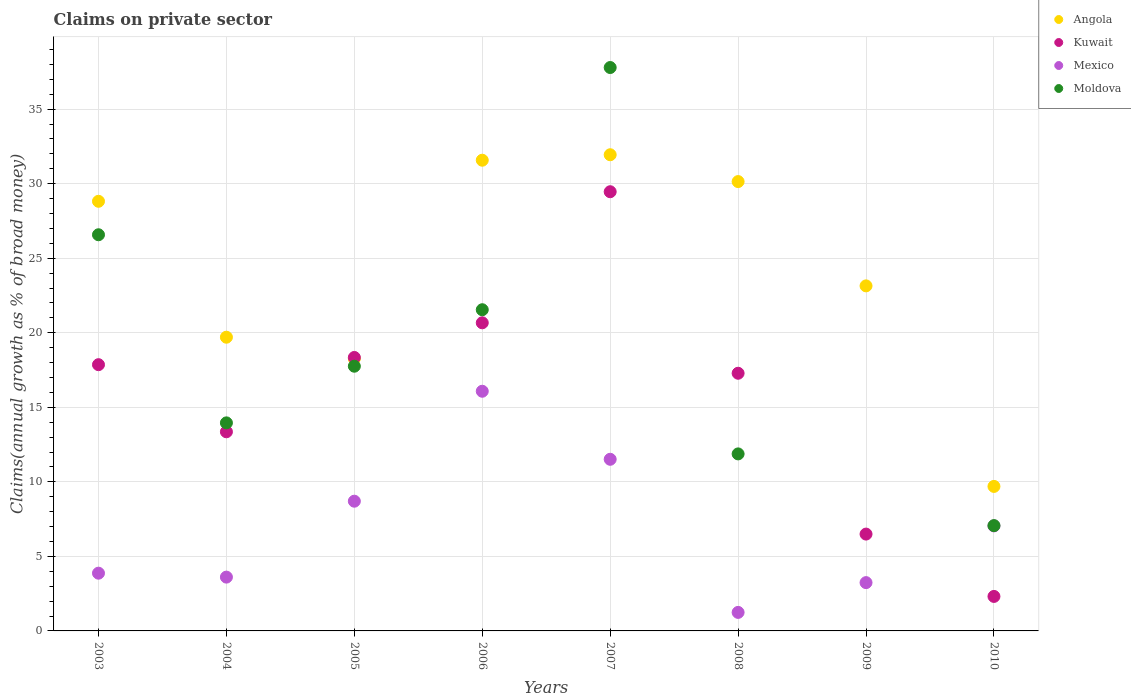How many different coloured dotlines are there?
Your answer should be compact. 4. Is the number of dotlines equal to the number of legend labels?
Give a very brief answer. No. What is the percentage of broad money claimed on private sector in Mexico in 2006?
Give a very brief answer. 16.08. Across all years, what is the maximum percentage of broad money claimed on private sector in Angola?
Provide a succinct answer. 31.94. Across all years, what is the minimum percentage of broad money claimed on private sector in Angola?
Offer a terse response. 9.69. What is the total percentage of broad money claimed on private sector in Angola in the graph?
Ensure brevity in your answer.  193.27. What is the difference between the percentage of broad money claimed on private sector in Kuwait in 2008 and that in 2009?
Provide a succinct answer. 10.79. What is the difference between the percentage of broad money claimed on private sector in Kuwait in 2005 and the percentage of broad money claimed on private sector in Moldova in 2009?
Give a very brief answer. 18.34. What is the average percentage of broad money claimed on private sector in Mexico per year?
Give a very brief answer. 6.91. In the year 2010, what is the difference between the percentage of broad money claimed on private sector in Moldova and percentage of broad money claimed on private sector in Kuwait?
Your answer should be compact. 4.75. In how many years, is the percentage of broad money claimed on private sector in Angola greater than 17 %?
Your answer should be compact. 7. What is the ratio of the percentage of broad money claimed on private sector in Kuwait in 2005 to that in 2010?
Your answer should be very brief. 7.93. What is the difference between the highest and the second highest percentage of broad money claimed on private sector in Angola?
Provide a succinct answer. 0.37. What is the difference between the highest and the lowest percentage of broad money claimed on private sector in Angola?
Provide a short and direct response. 22.25. In how many years, is the percentage of broad money claimed on private sector in Mexico greater than the average percentage of broad money claimed on private sector in Mexico taken over all years?
Give a very brief answer. 4. Is the sum of the percentage of broad money claimed on private sector in Angola in 2008 and 2010 greater than the maximum percentage of broad money claimed on private sector in Kuwait across all years?
Provide a succinct answer. Yes. Is it the case that in every year, the sum of the percentage of broad money claimed on private sector in Moldova and percentage of broad money claimed on private sector in Angola  is greater than the percentage of broad money claimed on private sector in Mexico?
Your answer should be very brief. Yes. Does the percentage of broad money claimed on private sector in Angola monotonically increase over the years?
Give a very brief answer. No. How many dotlines are there?
Provide a succinct answer. 4. Are the values on the major ticks of Y-axis written in scientific E-notation?
Your response must be concise. No. Does the graph contain grids?
Make the answer very short. Yes. What is the title of the graph?
Give a very brief answer. Claims on private sector. Does "OECD members" appear as one of the legend labels in the graph?
Offer a very short reply. No. What is the label or title of the X-axis?
Give a very brief answer. Years. What is the label or title of the Y-axis?
Your response must be concise. Claims(annual growth as % of broad money). What is the Claims(annual growth as % of broad money) in Angola in 2003?
Your response must be concise. 28.82. What is the Claims(annual growth as % of broad money) of Kuwait in 2003?
Your response must be concise. 17.86. What is the Claims(annual growth as % of broad money) in Mexico in 2003?
Your response must be concise. 3.87. What is the Claims(annual growth as % of broad money) of Moldova in 2003?
Offer a very short reply. 26.57. What is the Claims(annual growth as % of broad money) of Angola in 2004?
Offer a very short reply. 19.7. What is the Claims(annual growth as % of broad money) in Kuwait in 2004?
Provide a succinct answer. 13.36. What is the Claims(annual growth as % of broad money) in Mexico in 2004?
Ensure brevity in your answer.  3.61. What is the Claims(annual growth as % of broad money) of Moldova in 2004?
Ensure brevity in your answer.  13.96. What is the Claims(annual growth as % of broad money) of Angola in 2005?
Offer a very short reply. 18.26. What is the Claims(annual growth as % of broad money) of Kuwait in 2005?
Your answer should be compact. 18.34. What is the Claims(annual growth as % of broad money) in Mexico in 2005?
Your answer should be compact. 8.7. What is the Claims(annual growth as % of broad money) in Moldova in 2005?
Keep it short and to the point. 17.76. What is the Claims(annual growth as % of broad money) of Angola in 2006?
Offer a terse response. 31.57. What is the Claims(annual growth as % of broad money) of Kuwait in 2006?
Ensure brevity in your answer.  20.67. What is the Claims(annual growth as % of broad money) of Mexico in 2006?
Your answer should be very brief. 16.08. What is the Claims(annual growth as % of broad money) in Moldova in 2006?
Make the answer very short. 21.54. What is the Claims(annual growth as % of broad money) in Angola in 2007?
Keep it short and to the point. 31.94. What is the Claims(annual growth as % of broad money) in Kuwait in 2007?
Your answer should be very brief. 29.46. What is the Claims(annual growth as % of broad money) of Mexico in 2007?
Your response must be concise. 11.51. What is the Claims(annual growth as % of broad money) of Moldova in 2007?
Offer a terse response. 37.79. What is the Claims(annual growth as % of broad money) in Angola in 2008?
Give a very brief answer. 30.14. What is the Claims(annual growth as % of broad money) in Kuwait in 2008?
Ensure brevity in your answer.  17.28. What is the Claims(annual growth as % of broad money) in Mexico in 2008?
Make the answer very short. 1.24. What is the Claims(annual growth as % of broad money) of Moldova in 2008?
Your response must be concise. 11.87. What is the Claims(annual growth as % of broad money) of Angola in 2009?
Give a very brief answer. 23.14. What is the Claims(annual growth as % of broad money) in Kuwait in 2009?
Make the answer very short. 6.5. What is the Claims(annual growth as % of broad money) in Mexico in 2009?
Offer a terse response. 3.24. What is the Claims(annual growth as % of broad money) in Angola in 2010?
Give a very brief answer. 9.69. What is the Claims(annual growth as % of broad money) of Kuwait in 2010?
Provide a short and direct response. 2.31. What is the Claims(annual growth as % of broad money) in Mexico in 2010?
Keep it short and to the point. 7.04. What is the Claims(annual growth as % of broad money) in Moldova in 2010?
Your response must be concise. 7.06. Across all years, what is the maximum Claims(annual growth as % of broad money) of Angola?
Your answer should be very brief. 31.94. Across all years, what is the maximum Claims(annual growth as % of broad money) in Kuwait?
Offer a very short reply. 29.46. Across all years, what is the maximum Claims(annual growth as % of broad money) in Mexico?
Your response must be concise. 16.08. Across all years, what is the maximum Claims(annual growth as % of broad money) of Moldova?
Make the answer very short. 37.79. Across all years, what is the minimum Claims(annual growth as % of broad money) of Angola?
Your answer should be very brief. 9.69. Across all years, what is the minimum Claims(annual growth as % of broad money) in Kuwait?
Give a very brief answer. 2.31. Across all years, what is the minimum Claims(annual growth as % of broad money) in Mexico?
Your answer should be compact. 1.24. Across all years, what is the minimum Claims(annual growth as % of broad money) of Moldova?
Offer a very short reply. 0. What is the total Claims(annual growth as % of broad money) in Angola in the graph?
Provide a short and direct response. 193.27. What is the total Claims(annual growth as % of broad money) in Kuwait in the graph?
Offer a terse response. 125.78. What is the total Claims(annual growth as % of broad money) in Mexico in the graph?
Your answer should be very brief. 55.3. What is the total Claims(annual growth as % of broad money) of Moldova in the graph?
Give a very brief answer. 136.55. What is the difference between the Claims(annual growth as % of broad money) of Angola in 2003 and that in 2004?
Ensure brevity in your answer.  9.12. What is the difference between the Claims(annual growth as % of broad money) of Kuwait in 2003 and that in 2004?
Offer a very short reply. 4.5. What is the difference between the Claims(annual growth as % of broad money) of Mexico in 2003 and that in 2004?
Keep it short and to the point. 0.26. What is the difference between the Claims(annual growth as % of broad money) in Moldova in 2003 and that in 2004?
Offer a terse response. 12.62. What is the difference between the Claims(annual growth as % of broad money) in Angola in 2003 and that in 2005?
Offer a terse response. 10.56. What is the difference between the Claims(annual growth as % of broad money) in Kuwait in 2003 and that in 2005?
Provide a short and direct response. -0.48. What is the difference between the Claims(annual growth as % of broad money) of Mexico in 2003 and that in 2005?
Your response must be concise. -4.83. What is the difference between the Claims(annual growth as % of broad money) in Moldova in 2003 and that in 2005?
Ensure brevity in your answer.  8.82. What is the difference between the Claims(annual growth as % of broad money) in Angola in 2003 and that in 2006?
Ensure brevity in your answer.  -2.75. What is the difference between the Claims(annual growth as % of broad money) in Kuwait in 2003 and that in 2006?
Provide a short and direct response. -2.81. What is the difference between the Claims(annual growth as % of broad money) in Mexico in 2003 and that in 2006?
Offer a very short reply. -12.2. What is the difference between the Claims(annual growth as % of broad money) in Moldova in 2003 and that in 2006?
Your answer should be compact. 5.03. What is the difference between the Claims(annual growth as % of broad money) in Angola in 2003 and that in 2007?
Offer a very short reply. -3.12. What is the difference between the Claims(annual growth as % of broad money) of Kuwait in 2003 and that in 2007?
Ensure brevity in your answer.  -11.6. What is the difference between the Claims(annual growth as % of broad money) of Mexico in 2003 and that in 2007?
Keep it short and to the point. -7.64. What is the difference between the Claims(annual growth as % of broad money) of Moldova in 2003 and that in 2007?
Keep it short and to the point. -11.22. What is the difference between the Claims(annual growth as % of broad money) of Angola in 2003 and that in 2008?
Offer a very short reply. -1.32. What is the difference between the Claims(annual growth as % of broad money) in Kuwait in 2003 and that in 2008?
Your response must be concise. 0.57. What is the difference between the Claims(annual growth as % of broad money) in Mexico in 2003 and that in 2008?
Give a very brief answer. 2.63. What is the difference between the Claims(annual growth as % of broad money) in Moldova in 2003 and that in 2008?
Offer a very short reply. 14.7. What is the difference between the Claims(annual growth as % of broad money) of Angola in 2003 and that in 2009?
Your answer should be compact. 5.67. What is the difference between the Claims(annual growth as % of broad money) of Kuwait in 2003 and that in 2009?
Offer a terse response. 11.36. What is the difference between the Claims(annual growth as % of broad money) in Mexico in 2003 and that in 2009?
Your answer should be compact. 0.63. What is the difference between the Claims(annual growth as % of broad money) in Angola in 2003 and that in 2010?
Your answer should be compact. 19.12. What is the difference between the Claims(annual growth as % of broad money) in Kuwait in 2003 and that in 2010?
Your answer should be compact. 15.54. What is the difference between the Claims(annual growth as % of broad money) of Mexico in 2003 and that in 2010?
Provide a succinct answer. -3.17. What is the difference between the Claims(annual growth as % of broad money) in Moldova in 2003 and that in 2010?
Provide a succinct answer. 19.51. What is the difference between the Claims(annual growth as % of broad money) in Angola in 2004 and that in 2005?
Give a very brief answer. 1.44. What is the difference between the Claims(annual growth as % of broad money) of Kuwait in 2004 and that in 2005?
Give a very brief answer. -4.99. What is the difference between the Claims(annual growth as % of broad money) in Mexico in 2004 and that in 2005?
Offer a very short reply. -5.09. What is the difference between the Claims(annual growth as % of broad money) of Moldova in 2004 and that in 2005?
Provide a succinct answer. -3.8. What is the difference between the Claims(annual growth as % of broad money) in Angola in 2004 and that in 2006?
Provide a succinct answer. -11.87. What is the difference between the Claims(annual growth as % of broad money) of Kuwait in 2004 and that in 2006?
Provide a succinct answer. -7.31. What is the difference between the Claims(annual growth as % of broad money) in Mexico in 2004 and that in 2006?
Make the answer very short. -12.47. What is the difference between the Claims(annual growth as % of broad money) of Moldova in 2004 and that in 2006?
Keep it short and to the point. -7.59. What is the difference between the Claims(annual growth as % of broad money) in Angola in 2004 and that in 2007?
Give a very brief answer. -12.24. What is the difference between the Claims(annual growth as % of broad money) of Kuwait in 2004 and that in 2007?
Your response must be concise. -16.1. What is the difference between the Claims(annual growth as % of broad money) of Mexico in 2004 and that in 2007?
Offer a terse response. -7.9. What is the difference between the Claims(annual growth as % of broad money) in Moldova in 2004 and that in 2007?
Offer a terse response. -23.84. What is the difference between the Claims(annual growth as % of broad money) in Angola in 2004 and that in 2008?
Your answer should be very brief. -10.44. What is the difference between the Claims(annual growth as % of broad money) of Kuwait in 2004 and that in 2008?
Make the answer very short. -3.93. What is the difference between the Claims(annual growth as % of broad money) of Mexico in 2004 and that in 2008?
Your answer should be compact. 2.37. What is the difference between the Claims(annual growth as % of broad money) in Moldova in 2004 and that in 2008?
Provide a succinct answer. 2.08. What is the difference between the Claims(annual growth as % of broad money) of Angola in 2004 and that in 2009?
Make the answer very short. -3.44. What is the difference between the Claims(annual growth as % of broad money) in Kuwait in 2004 and that in 2009?
Offer a very short reply. 6.86. What is the difference between the Claims(annual growth as % of broad money) in Mexico in 2004 and that in 2009?
Offer a very short reply. 0.37. What is the difference between the Claims(annual growth as % of broad money) of Angola in 2004 and that in 2010?
Keep it short and to the point. 10.01. What is the difference between the Claims(annual growth as % of broad money) in Kuwait in 2004 and that in 2010?
Make the answer very short. 11.04. What is the difference between the Claims(annual growth as % of broad money) of Mexico in 2004 and that in 2010?
Ensure brevity in your answer.  -3.44. What is the difference between the Claims(annual growth as % of broad money) of Moldova in 2004 and that in 2010?
Your answer should be very brief. 6.89. What is the difference between the Claims(annual growth as % of broad money) in Angola in 2005 and that in 2006?
Your response must be concise. -13.31. What is the difference between the Claims(annual growth as % of broad money) of Kuwait in 2005 and that in 2006?
Offer a terse response. -2.32. What is the difference between the Claims(annual growth as % of broad money) in Mexico in 2005 and that in 2006?
Provide a succinct answer. -7.37. What is the difference between the Claims(annual growth as % of broad money) in Moldova in 2005 and that in 2006?
Your answer should be compact. -3.79. What is the difference between the Claims(annual growth as % of broad money) in Angola in 2005 and that in 2007?
Give a very brief answer. -13.68. What is the difference between the Claims(annual growth as % of broad money) of Kuwait in 2005 and that in 2007?
Your answer should be very brief. -11.12. What is the difference between the Claims(annual growth as % of broad money) in Mexico in 2005 and that in 2007?
Provide a short and direct response. -2.81. What is the difference between the Claims(annual growth as % of broad money) in Moldova in 2005 and that in 2007?
Keep it short and to the point. -20.04. What is the difference between the Claims(annual growth as % of broad money) of Angola in 2005 and that in 2008?
Make the answer very short. -11.88. What is the difference between the Claims(annual growth as % of broad money) of Kuwait in 2005 and that in 2008?
Make the answer very short. 1.06. What is the difference between the Claims(annual growth as % of broad money) in Mexico in 2005 and that in 2008?
Your response must be concise. 7.46. What is the difference between the Claims(annual growth as % of broad money) of Moldova in 2005 and that in 2008?
Provide a short and direct response. 5.88. What is the difference between the Claims(annual growth as % of broad money) in Angola in 2005 and that in 2009?
Offer a terse response. -4.88. What is the difference between the Claims(annual growth as % of broad money) of Kuwait in 2005 and that in 2009?
Provide a succinct answer. 11.85. What is the difference between the Claims(annual growth as % of broad money) in Mexico in 2005 and that in 2009?
Your response must be concise. 5.46. What is the difference between the Claims(annual growth as % of broad money) of Angola in 2005 and that in 2010?
Make the answer very short. 8.57. What is the difference between the Claims(annual growth as % of broad money) of Kuwait in 2005 and that in 2010?
Provide a short and direct response. 16.03. What is the difference between the Claims(annual growth as % of broad money) in Mexico in 2005 and that in 2010?
Offer a very short reply. 1.66. What is the difference between the Claims(annual growth as % of broad money) in Moldova in 2005 and that in 2010?
Your answer should be compact. 10.69. What is the difference between the Claims(annual growth as % of broad money) in Angola in 2006 and that in 2007?
Your answer should be very brief. -0.37. What is the difference between the Claims(annual growth as % of broad money) in Kuwait in 2006 and that in 2007?
Keep it short and to the point. -8.79. What is the difference between the Claims(annual growth as % of broad money) of Mexico in 2006 and that in 2007?
Provide a short and direct response. 4.56. What is the difference between the Claims(annual growth as % of broad money) in Moldova in 2006 and that in 2007?
Provide a succinct answer. -16.25. What is the difference between the Claims(annual growth as % of broad money) of Angola in 2006 and that in 2008?
Provide a succinct answer. 1.43. What is the difference between the Claims(annual growth as % of broad money) in Kuwait in 2006 and that in 2008?
Your answer should be compact. 3.38. What is the difference between the Claims(annual growth as % of broad money) in Mexico in 2006 and that in 2008?
Your response must be concise. 14.83. What is the difference between the Claims(annual growth as % of broad money) of Moldova in 2006 and that in 2008?
Your response must be concise. 9.67. What is the difference between the Claims(annual growth as % of broad money) of Angola in 2006 and that in 2009?
Provide a succinct answer. 8.43. What is the difference between the Claims(annual growth as % of broad money) in Kuwait in 2006 and that in 2009?
Give a very brief answer. 14.17. What is the difference between the Claims(annual growth as % of broad money) in Mexico in 2006 and that in 2009?
Your answer should be compact. 12.84. What is the difference between the Claims(annual growth as % of broad money) in Angola in 2006 and that in 2010?
Offer a terse response. 21.88. What is the difference between the Claims(annual growth as % of broad money) of Kuwait in 2006 and that in 2010?
Your answer should be compact. 18.35. What is the difference between the Claims(annual growth as % of broad money) of Mexico in 2006 and that in 2010?
Provide a short and direct response. 9.03. What is the difference between the Claims(annual growth as % of broad money) in Moldova in 2006 and that in 2010?
Offer a terse response. 14.48. What is the difference between the Claims(annual growth as % of broad money) of Angola in 2007 and that in 2008?
Provide a succinct answer. 1.8. What is the difference between the Claims(annual growth as % of broad money) in Kuwait in 2007 and that in 2008?
Your answer should be very brief. 12.18. What is the difference between the Claims(annual growth as % of broad money) of Mexico in 2007 and that in 2008?
Make the answer very short. 10.27. What is the difference between the Claims(annual growth as % of broad money) in Moldova in 2007 and that in 2008?
Ensure brevity in your answer.  25.92. What is the difference between the Claims(annual growth as % of broad money) in Angola in 2007 and that in 2009?
Keep it short and to the point. 8.8. What is the difference between the Claims(annual growth as % of broad money) of Kuwait in 2007 and that in 2009?
Provide a succinct answer. 22.96. What is the difference between the Claims(annual growth as % of broad money) in Mexico in 2007 and that in 2009?
Provide a short and direct response. 8.27. What is the difference between the Claims(annual growth as % of broad money) of Angola in 2007 and that in 2010?
Ensure brevity in your answer.  22.25. What is the difference between the Claims(annual growth as % of broad money) of Kuwait in 2007 and that in 2010?
Your response must be concise. 27.15. What is the difference between the Claims(annual growth as % of broad money) of Mexico in 2007 and that in 2010?
Provide a succinct answer. 4.47. What is the difference between the Claims(annual growth as % of broad money) in Moldova in 2007 and that in 2010?
Your answer should be compact. 30.73. What is the difference between the Claims(annual growth as % of broad money) in Angola in 2008 and that in 2009?
Offer a very short reply. 7. What is the difference between the Claims(annual growth as % of broad money) of Kuwait in 2008 and that in 2009?
Give a very brief answer. 10.79. What is the difference between the Claims(annual growth as % of broad money) in Mexico in 2008 and that in 2009?
Keep it short and to the point. -2. What is the difference between the Claims(annual growth as % of broad money) of Angola in 2008 and that in 2010?
Provide a short and direct response. 20.45. What is the difference between the Claims(annual growth as % of broad money) of Kuwait in 2008 and that in 2010?
Offer a very short reply. 14.97. What is the difference between the Claims(annual growth as % of broad money) in Mexico in 2008 and that in 2010?
Keep it short and to the point. -5.8. What is the difference between the Claims(annual growth as % of broad money) of Moldova in 2008 and that in 2010?
Your answer should be compact. 4.81. What is the difference between the Claims(annual growth as % of broad money) in Angola in 2009 and that in 2010?
Offer a terse response. 13.45. What is the difference between the Claims(annual growth as % of broad money) of Kuwait in 2009 and that in 2010?
Ensure brevity in your answer.  4.18. What is the difference between the Claims(annual growth as % of broad money) of Mexico in 2009 and that in 2010?
Provide a succinct answer. -3.8. What is the difference between the Claims(annual growth as % of broad money) of Angola in 2003 and the Claims(annual growth as % of broad money) of Kuwait in 2004?
Offer a very short reply. 15.46. What is the difference between the Claims(annual growth as % of broad money) of Angola in 2003 and the Claims(annual growth as % of broad money) of Mexico in 2004?
Ensure brevity in your answer.  25.21. What is the difference between the Claims(annual growth as % of broad money) of Angola in 2003 and the Claims(annual growth as % of broad money) of Moldova in 2004?
Offer a very short reply. 14.86. What is the difference between the Claims(annual growth as % of broad money) of Kuwait in 2003 and the Claims(annual growth as % of broad money) of Mexico in 2004?
Offer a terse response. 14.25. What is the difference between the Claims(annual growth as % of broad money) in Kuwait in 2003 and the Claims(annual growth as % of broad money) in Moldova in 2004?
Make the answer very short. 3.9. What is the difference between the Claims(annual growth as % of broad money) in Mexico in 2003 and the Claims(annual growth as % of broad money) in Moldova in 2004?
Make the answer very short. -10.08. What is the difference between the Claims(annual growth as % of broad money) of Angola in 2003 and the Claims(annual growth as % of broad money) of Kuwait in 2005?
Provide a succinct answer. 10.47. What is the difference between the Claims(annual growth as % of broad money) in Angola in 2003 and the Claims(annual growth as % of broad money) in Mexico in 2005?
Keep it short and to the point. 20.12. What is the difference between the Claims(annual growth as % of broad money) in Angola in 2003 and the Claims(annual growth as % of broad money) in Moldova in 2005?
Give a very brief answer. 11.06. What is the difference between the Claims(annual growth as % of broad money) of Kuwait in 2003 and the Claims(annual growth as % of broad money) of Mexico in 2005?
Ensure brevity in your answer.  9.16. What is the difference between the Claims(annual growth as % of broad money) of Kuwait in 2003 and the Claims(annual growth as % of broad money) of Moldova in 2005?
Ensure brevity in your answer.  0.1. What is the difference between the Claims(annual growth as % of broad money) of Mexico in 2003 and the Claims(annual growth as % of broad money) of Moldova in 2005?
Keep it short and to the point. -13.88. What is the difference between the Claims(annual growth as % of broad money) in Angola in 2003 and the Claims(annual growth as % of broad money) in Kuwait in 2006?
Your answer should be compact. 8.15. What is the difference between the Claims(annual growth as % of broad money) in Angola in 2003 and the Claims(annual growth as % of broad money) in Mexico in 2006?
Provide a short and direct response. 12.74. What is the difference between the Claims(annual growth as % of broad money) in Angola in 2003 and the Claims(annual growth as % of broad money) in Moldova in 2006?
Provide a short and direct response. 7.27. What is the difference between the Claims(annual growth as % of broad money) in Kuwait in 2003 and the Claims(annual growth as % of broad money) in Mexico in 2006?
Ensure brevity in your answer.  1.78. What is the difference between the Claims(annual growth as % of broad money) of Kuwait in 2003 and the Claims(annual growth as % of broad money) of Moldova in 2006?
Provide a succinct answer. -3.69. What is the difference between the Claims(annual growth as % of broad money) in Mexico in 2003 and the Claims(annual growth as % of broad money) in Moldova in 2006?
Offer a very short reply. -17.67. What is the difference between the Claims(annual growth as % of broad money) in Angola in 2003 and the Claims(annual growth as % of broad money) in Kuwait in 2007?
Offer a very short reply. -0.64. What is the difference between the Claims(annual growth as % of broad money) in Angola in 2003 and the Claims(annual growth as % of broad money) in Mexico in 2007?
Your answer should be very brief. 17.31. What is the difference between the Claims(annual growth as % of broad money) of Angola in 2003 and the Claims(annual growth as % of broad money) of Moldova in 2007?
Provide a succinct answer. -8.97. What is the difference between the Claims(annual growth as % of broad money) of Kuwait in 2003 and the Claims(annual growth as % of broad money) of Mexico in 2007?
Keep it short and to the point. 6.35. What is the difference between the Claims(annual growth as % of broad money) of Kuwait in 2003 and the Claims(annual growth as % of broad money) of Moldova in 2007?
Your response must be concise. -19.93. What is the difference between the Claims(annual growth as % of broad money) of Mexico in 2003 and the Claims(annual growth as % of broad money) of Moldova in 2007?
Ensure brevity in your answer.  -33.92. What is the difference between the Claims(annual growth as % of broad money) in Angola in 2003 and the Claims(annual growth as % of broad money) in Kuwait in 2008?
Make the answer very short. 11.53. What is the difference between the Claims(annual growth as % of broad money) in Angola in 2003 and the Claims(annual growth as % of broad money) in Mexico in 2008?
Your response must be concise. 27.58. What is the difference between the Claims(annual growth as % of broad money) in Angola in 2003 and the Claims(annual growth as % of broad money) in Moldova in 2008?
Ensure brevity in your answer.  16.94. What is the difference between the Claims(annual growth as % of broad money) of Kuwait in 2003 and the Claims(annual growth as % of broad money) of Mexico in 2008?
Offer a terse response. 16.62. What is the difference between the Claims(annual growth as % of broad money) in Kuwait in 2003 and the Claims(annual growth as % of broad money) in Moldova in 2008?
Make the answer very short. 5.98. What is the difference between the Claims(annual growth as % of broad money) in Mexico in 2003 and the Claims(annual growth as % of broad money) in Moldova in 2008?
Provide a succinct answer. -8. What is the difference between the Claims(annual growth as % of broad money) in Angola in 2003 and the Claims(annual growth as % of broad money) in Kuwait in 2009?
Offer a terse response. 22.32. What is the difference between the Claims(annual growth as % of broad money) in Angola in 2003 and the Claims(annual growth as % of broad money) in Mexico in 2009?
Offer a terse response. 25.58. What is the difference between the Claims(annual growth as % of broad money) in Kuwait in 2003 and the Claims(annual growth as % of broad money) in Mexico in 2009?
Provide a succinct answer. 14.62. What is the difference between the Claims(annual growth as % of broad money) in Angola in 2003 and the Claims(annual growth as % of broad money) in Kuwait in 2010?
Give a very brief answer. 26.5. What is the difference between the Claims(annual growth as % of broad money) of Angola in 2003 and the Claims(annual growth as % of broad money) of Mexico in 2010?
Your answer should be very brief. 21.77. What is the difference between the Claims(annual growth as % of broad money) of Angola in 2003 and the Claims(annual growth as % of broad money) of Moldova in 2010?
Keep it short and to the point. 21.75. What is the difference between the Claims(annual growth as % of broad money) in Kuwait in 2003 and the Claims(annual growth as % of broad money) in Mexico in 2010?
Offer a very short reply. 10.81. What is the difference between the Claims(annual growth as % of broad money) of Kuwait in 2003 and the Claims(annual growth as % of broad money) of Moldova in 2010?
Provide a short and direct response. 10.8. What is the difference between the Claims(annual growth as % of broad money) of Mexico in 2003 and the Claims(annual growth as % of broad money) of Moldova in 2010?
Provide a short and direct response. -3.19. What is the difference between the Claims(annual growth as % of broad money) of Angola in 2004 and the Claims(annual growth as % of broad money) of Kuwait in 2005?
Give a very brief answer. 1.36. What is the difference between the Claims(annual growth as % of broad money) in Angola in 2004 and the Claims(annual growth as % of broad money) in Mexico in 2005?
Keep it short and to the point. 11. What is the difference between the Claims(annual growth as % of broad money) in Angola in 2004 and the Claims(annual growth as % of broad money) in Moldova in 2005?
Offer a terse response. 1.95. What is the difference between the Claims(annual growth as % of broad money) in Kuwait in 2004 and the Claims(annual growth as % of broad money) in Mexico in 2005?
Offer a terse response. 4.66. What is the difference between the Claims(annual growth as % of broad money) of Kuwait in 2004 and the Claims(annual growth as % of broad money) of Moldova in 2005?
Offer a terse response. -4.4. What is the difference between the Claims(annual growth as % of broad money) in Mexico in 2004 and the Claims(annual growth as % of broad money) in Moldova in 2005?
Keep it short and to the point. -14.15. What is the difference between the Claims(annual growth as % of broad money) of Angola in 2004 and the Claims(annual growth as % of broad money) of Kuwait in 2006?
Provide a short and direct response. -0.97. What is the difference between the Claims(annual growth as % of broad money) in Angola in 2004 and the Claims(annual growth as % of broad money) in Mexico in 2006?
Make the answer very short. 3.63. What is the difference between the Claims(annual growth as % of broad money) in Angola in 2004 and the Claims(annual growth as % of broad money) in Moldova in 2006?
Give a very brief answer. -1.84. What is the difference between the Claims(annual growth as % of broad money) in Kuwait in 2004 and the Claims(annual growth as % of broad money) in Mexico in 2006?
Make the answer very short. -2.72. What is the difference between the Claims(annual growth as % of broad money) of Kuwait in 2004 and the Claims(annual growth as % of broad money) of Moldova in 2006?
Make the answer very short. -8.19. What is the difference between the Claims(annual growth as % of broad money) of Mexico in 2004 and the Claims(annual growth as % of broad money) of Moldova in 2006?
Make the answer very short. -17.94. What is the difference between the Claims(annual growth as % of broad money) in Angola in 2004 and the Claims(annual growth as % of broad money) in Kuwait in 2007?
Your answer should be very brief. -9.76. What is the difference between the Claims(annual growth as % of broad money) in Angola in 2004 and the Claims(annual growth as % of broad money) in Mexico in 2007?
Keep it short and to the point. 8.19. What is the difference between the Claims(annual growth as % of broad money) in Angola in 2004 and the Claims(annual growth as % of broad money) in Moldova in 2007?
Offer a very short reply. -18.09. What is the difference between the Claims(annual growth as % of broad money) of Kuwait in 2004 and the Claims(annual growth as % of broad money) of Mexico in 2007?
Your answer should be very brief. 1.84. What is the difference between the Claims(annual growth as % of broad money) in Kuwait in 2004 and the Claims(annual growth as % of broad money) in Moldova in 2007?
Ensure brevity in your answer.  -24.43. What is the difference between the Claims(annual growth as % of broad money) of Mexico in 2004 and the Claims(annual growth as % of broad money) of Moldova in 2007?
Provide a short and direct response. -34.18. What is the difference between the Claims(annual growth as % of broad money) of Angola in 2004 and the Claims(annual growth as % of broad money) of Kuwait in 2008?
Your answer should be very brief. 2.42. What is the difference between the Claims(annual growth as % of broad money) in Angola in 2004 and the Claims(annual growth as % of broad money) in Mexico in 2008?
Make the answer very short. 18.46. What is the difference between the Claims(annual growth as % of broad money) in Angola in 2004 and the Claims(annual growth as % of broad money) in Moldova in 2008?
Give a very brief answer. 7.83. What is the difference between the Claims(annual growth as % of broad money) of Kuwait in 2004 and the Claims(annual growth as % of broad money) of Mexico in 2008?
Provide a succinct answer. 12.11. What is the difference between the Claims(annual growth as % of broad money) of Kuwait in 2004 and the Claims(annual growth as % of broad money) of Moldova in 2008?
Ensure brevity in your answer.  1.48. What is the difference between the Claims(annual growth as % of broad money) of Mexico in 2004 and the Claims(annual growth as % of broad money) of Moldova in 2008?
Your answer should be very brief. -8.26. What is the difference between the Claims(annual growth as % of broad money) in Angola in 2004 and the Claims(annual growth as % of broad money) in Kuwait in 2009?
Ensure brevity in your answer.  13.21. What is the difference between the Claims(annual growth as % of broad money) of Angola in 2004 and the Claims(annual growth as % of broad money) of Mexico in 2009?
Your answer should be compact. 16.46. What is the difference between the Claims(annual growth as % of broad money) in Kuwait in 2004 and the Claims(annual growth as % of broad money) in Mexico in 2009?
Offer a terse response. 10.12. What is the difference between the Claims(annual growth as % of broad money) of Angola in 2004 and the Claims(annual growth as % of broad money) of Kuwait in 2010?
Provide a short and direct response. 17.39. What is the difference between the Claims(annual growth as % of broad money) of Angola in 2004 and the Claims(annual growth as % of broad money) of Mexico in 2010?
Your answer should be compact. 12.66. What is the difference between the Claims(annual growth as % of broad money) in Angola in 2004 and the Claims(annual growth as % of broad money) in Moldova in 2010?
Give a very brief answer. 12.64. What is the difference between the Claims(annual growth as % of broad money) in Kuwait in 2004 and the Claims(annual growth as % of broad money) in Mexico in 2010?
Provide a succinct answer. 6.31. What is the difference between the Claims(annual growth as % of broad money) in Kuwait in 2004 and the Claims(annual growth as % of broad money) in Moldova in 2010?
Ensure brevity in your answer.  6.29. What is the difference between the Claims(annual growth as % of broad money) in Mexico in 2004 and the Claims(annual growth as % of broad money) in Moldova in 2010?
Give a very brief answer. -3.45. What is the difference between the Claims(annual growth as % of broad money) of Angola in 2005 and the Claims(annual growth as % of broad money) of Kuwait in 2006?
Offer a terse response. -2.41. What is the difference between the Claims(annual growth as % of broad money) of Angola in 2005 and the Claims(annual growth as % of broad money) of Mexico in 2006?
Provide a succinct answer. 2.18. What is the difference between the Claims(annual growth as % of broad money) of Angola in 2005 and the Claims(annual growth as % of broad money) of Moldova in 2006?
Your answer should be compact. -3.28. What is the difference between the Claims(annual growth as % of broad money) in Kuwait in 2005 and the Claims(annual growth as % of broad money) in Mexico in 2006?
Provide a succinct answer. 2.27. What is the difference between the Claims(annual growth as % of broad money) of Kuwait in 2005 and the Claims(annual growth as % of broad money) of Moldova in 2006?
Offer a terse response. -3.2. What is the difference between the Claims(annual growth as % of broad money) of Mexico in 2005 and the Claims(annual growth as % of broad money) of Moldova in 2006?
Ensure brevity in your answer.  -12.84. What is the difference between the Claims(annual growth as % of broad money) of Angola in 2005 and the Claims(annual growth as % of broad money) of Kuwait in 2007?
Offer a terse response. -11.2. What is the difference between the Claims(annual growth as % of broad money) in Angola in 2005 and the Claims(annual growth as % of broad money) in Mexico in 2007?
Give a very brief answer. 6.75. What is the difference between the Claims(annual growth as % of broad money) of Angola in 2005 and the Claims(annual growth as % of broad money) of Moldova in 2007?
Offer a very short reply. -19.53. What is the difference between the Claims(annual growth as % of broad money) of Kuwait in 2005 and the Claims(annual growth as % of broad money) of Mexico in 2007?
Make the answer very short. 6.83. What is the difference between the Claims(annual growth as % of broad money) of Kuwait in 2005 and the Claims(annual growth as % of broad money) of Moldova in 2007?
Your answer should be compact. -19.45. What is the difference between the Claims(annual growth as % of broad money) of Mexico in 2005 and the Claims(annual growth as % of broad money) of Moldova in 2007?
Give a very brief answer. -29.09. What is the difference between the Claims(annual growth as % of broad money) in Angola in 2005 and the Claims(annual growth as % of broad money) in Kuwait in 2008?
Offer a terse response. 0.98. What is the difference between the Claims(annual growth as % of broad money) of Angola in 2005 and the Claims(annual growth as % of broad money) of Mexico in 2008?
Your response must be concise. 17.02. What is the difference between the Claims(annual growth as % of broad money) of Angola in 2005 and the Claims(annual growth as % of broad money) of Moldova in 2008?
Your response must be concise. 6.39. What is the difference between the Claims(annual growth as % of broad money) in Kuwait in 2005 and the Claims(annual growth as % of broad money) in Mexico in 2008?
Provide a succinct answer. 17.1. What is the difference between the Claims(annual growth as % of broad money) in Kuwait in 2005 and the Claims(annual growth as % of broad money) in Moldova in 2008?
Keep it short and to the point. 6.47. What is the difference between the Claims(annual growth as % of broad money) of Mexico in 2005 and the Claims(annual growth as % of broad money) of Moldova in 2008?
Make the answer very short. -3.17. What is the difference between the Claims(annual growth as % of broad money) in Angola in 2005 and the Claims(annual growth as % of broad money) in Kuwait in 2009?
Your answer should be very brief. 11.77. What is the difference between the Claims(annual growth as % of broad money) of Angola in 2005 and the Claims(annual growth as % of broad money) of Mexico in 2009?
Provide a short and direct response. 15.02. What is the difference between the Claims(annual growth as % of broad money) in Kuwait in 2005 and the Claims(annual growth as % of broad money) in Mexico in 2009?
Your answer should be very brief. 15.1. What is the difference between the Claims(annual growth as % of broad money) of Angola in 2005 and the Claims(annual growth as % of broad money) of Kuwait in 2010?
Offer a terse response. 15.95. What is the difference between the Claims(annual growth as % of broad money) in Angola in 2005 and the Claims(annual growth as % of broad money) in Mexico in 2010?
Ensure brevity in your answer.  11.22. What is the difference between the Claims(annual growth as % of broad money) of Angola in 2005 and the Claims(annual growth as % of broad money) of Moldova in 2010?
Offer a terse response. 11.2. What is the difference between the Claims(annual growth as % of broad money) in Kuwait in 2005 and the Claims(annual growth as % of broad money) in Mexico in 2010?
Give a very brief answer. 11.3. What is the difference between the Claims(annual growth as % of broad money) of Kuwait in 2005 and the Claims(annual growth as % of broad money) of Moldova in 2010?
Offer a very short reply. 11.28. What is the difference between the Claims(annual growth as % of broad money) in Mexico in 2005 and the Claims(annual growth as % of broad money) in Moldova in 2010?
Give a very brief answer. 1.64. What is the difference between the Claims(annual growth as % of broad money) in Angola in 2006 and the Claims(annual growth as % of broad money) in Kuwait in 2007?
Your answer should be very brief. 2.11. What is the difference between the Claims(annual growth as % of broad money) in Angola in 2006 and the Claims(annual growth as % of broad money) in Mexico in 2007?
Your response must be concise. 20.06. What is the difference between the Claims(annual growth as % of broad money) of Angola in 2006 and the Claims(annual growth as % of broad money) of Moldova in 2007?
Offer a terse response. -6.22. What is the difference between the Claims(annual growth as % of broad money) in Kuwait in 2006 and the Claims(annual growth as % of broad money) in Mexico in 2007?
Keep it short and to the point. 9.16. What is the difference between the Claims(annual growth as % of broad money) in Kuwait in 2006 and the Claims(annual growth as % of broad money) in Moldova in 2007?
Your answer should be compact. -17.12. What is the difference between the Claims(annual growth as % of broad money) in Mexico in 2006 and the Claims(annual growth as % of broad money) in Moldova in 2007?
Keep it short and to the point. -21.71. What is the difference between the Claims(annual growth as % of broad money) in Angola in 2006 and the Claims(annual growth as % of broad money) in Kuwait in 2008?
Provide a succinct answer. 14.29. What is the difference between the Claims(annual growth as % of broad money) of Angola in 2006 and the Claims(annual growth as % of broad money) of Mexico in 2008?
Keep it short and to the point. 30.33. What is the difference between the Claims(annual growth as % of broad money) in Angola in 2006 and the Claims(annual growth as % of broad money) in Moldova in 2008?
Provide a succinct answer. 19.7. What is the difference between the Claims(annual growth as % of broad money) of Kuwait in 2006 and the Claims(annual growth as % of broad money) of Mexico in 2008?
Your answer should be compact. 19.43. What is the difference between the Claims(annual growth as % of broad money) in Kuwait in 2006 and the Claims(annual growth as % of broad money) in Moldova in 2008?
Your response must be concise. 8.79. What is the difference between the Claims(annual growth as % of broad money) in Mexico in 2006 and the Claims(annual growth as % of broad money) in Moldova in 2008?
Ensure brevity in your answer.  4.2. What is the difference between the Claims(annual growth as % of broad money) in Angola in 2006 and the Claims(annual growth as % of broad money) in Kuwait in 2009?
Ensure brevity in your answer.  25.08. What is the difference between the Claims(annual growth as % of broad money) in Angola in 2006 and the Claims(annual growth as % of broad money) in Mexico in 2009?
Your response must be concise. 28.33. What is the difference between the Claims(annual growth as % of broad money) in Kuwait in 2006 and the Claims(annual growth as % of broad money) in Mexico in 2009?
Ensure brevity in your answer.  17.43. What is the difference between the Claims(annual growth as % of broad money) of Angola in 2006 and the Claims(annual growth as % of broad money) of Kuwait in 2010?
Make the answer very short. 29.26. What is the difference between the Claims(annual growth as % of broad money) in Angola in 2006 and the Claims(annual growth as % of broad money) in Mexico in 2010?
Offer a very short reply. 24.53. What is the difference between the Claims(annual growth as % of broad money) of Angola in 2006 and the Claims(annual growth as % of broad money) of Moldova in 2010?
Your response must be concise. 24.51. What is the difference between the Claims(annual growth as % of broad money) of Kuwait in 2006 and the Claims(annual growth as % of broad money) of Mexico in 2010?
Your answer should be very brief. 13.62. What is the difference between the Claims(annual growth as % of broad money) of Kuwait in 2006 and the Claims(annual growth as % of broad money) of Moldova in 2010?
Your answer should be very brief. 13.6. What is the difference between the Claims(annual growth as % of broad money) in Mexico in 2006 and the Claims(annual growth as % of broad money) in Moldova in 2010?
Make the answer very short. 9.01. What is the difference between the Claims(annual growth as % of broad money) of Angola in 2007 and the Claims(annual growth as % of broad money) of Kuwait in 2008?
Provide a succinct answer. 14.66. What is the difference between the Claims(annual growth as % of broad money) in Angola in 2007 and the Claims(annual growth as % of broad money) in Mexico in 2008?
Give a very brief answer. 30.7. What is the difference between the Claims(annual growth as % of broad money) in Angola in 2007 and the Claims(annual growth as % of broad money) in Moldova in 2008?
Your answer should be very brief. 20.07. What is the difference between the Claims(annual growth as % of broad money) of Kuwait in 2007 and the Claims(annual growth as % of broad money) of Mexico in 2008?
Your answer should be compact. 28.22. What is the difference between the Claims(annual growth as % of broad money) of Kuwait in 2007 and the Claims(annual growth as % of broad money) of Moldova in 2008?
Your response must be concise. 17.59. What is the difference between the Claims(annual growth as % of broad money) in Mexico in 2007 and the Claims(annual growth as % of broad money) in Moldova in 2008?
Your answer should be compact. -0.36. What is the difference between the Claims(annual growth as % of broad money) in Angola in 2007 and the Claims(annual growth as % of broad money) in Kuwait in 2009?
Your answer should be compact. 25.45. What is the difference between the Claims(annual growth as % of broad money) of Angola in 2007 and the Claims(annual growth as % of broad money) of Mexico in 2009?
Your answer should be compact. 28.7. What is the difference between the Claims(annual growth as % of broad money) in Kuwait in 2007 and the Claims(annual growth as % of broad money) in Mexico in 2009?
Offer a terse response. 26.22. What is the difference between the Claims(annual growth as % of broad money) of Angola in 2007 and the Claims(annual growth as % of broad money) of Kuwait in 2010?
Give a very brief answer. 29.63. What is the difference between the Claims(annual growth as % of broad money) in Angola in 2007 and the Claims(annual growth as % of broad money) in Mexico in 2010?
Your answer should be compact. 24.9. What is the difference between the Claims(annual growth as % of broad money) in Angola in 2007 and the Claims(annual growth as % of broad money) in Moldova in 2010?
Your response must be concise. 24.88. What is the difference between the Claims(annual growth as % of broad money) of Kuwait in 2007 and the Claims(annual growth as % of broad money) of Mexico in 2010?
Your answer should be very brief. 22.42. What is the difference between the Claims(annual growth as % of broad money) in Kuwait in 2007 and the Claims(annual growth as % of broad money) in Moldova in 2010?
Your answer should be compact. 22.4. What is the difference between the Claims(annual growth as % of broad money) of Mexico in 2007 and the Claims(annual growth as % of broad money) of Moldova in 2010?
Provide a short and direct response. 4.45. What is the difference between the Claims(annual growth as % of broad money) in Angola in 2008 and the Claims(annual growth as % of broad money) in Kuwait in 2009?
Your response must be concise. 23.65. What is the difference between the Claims(annual growth as % of broad money) in Angola in 2008 and the Claims(annual growth as % of broad money) in Mexico in 2009?
Ensure brevity in your answer.  26.9. What is the difference between the Claims(annual growth as % of broad money) in Kuwait in 2008 and the Claims(annual growth as % of broad money) in Mexico in 2009?
Offer a very short reply. 14.04. What is the difference between the Claims(annual growth as % of broad money) of Angola in 2008 and the Claims(annual growth as % of broad money) of Kuwait in 2010?
Your response must be concise. 27.83. What is the difference between the Claims(annual growth as % of broad money) in Angola in 2008 and the Claims(annual growth as % of broad money) in Mexico in 2010?
Keep it short and to the point. 23.1. What is the difference between the Claims(annual growth as % of broad money) of Angola in 2008 and the Claims(annual growth as % of broad money) of Moldova in 2010?
Provide a succinct answer. 23.08. What is the difference between the Claims(annual growth as % of broad money) in Kuwait in 2008 and the Claims(annual growth as % of broad money) in Mexico in 2010?
Offer a terse response. 10.24. What is the difference between the Claims(annual growth as % of broad money) of Kuwait in 2008 and the Claims(annual growth as % of broad money) of Moldova in 2010?
Give a very brief answer. 10.22. What is the difference between the Claims(annual growth as % of broad money) of Mexico in 2008 and the Claims(annual growth as % of broad money) of Moldova in 2010?
Make the answer very short. -5.82. What is the difference between the Claims(annual growth as % of broad money) in Angola in 2009 and the Claims(annual growth as % of broad money) in Kuwait in 2010?
Offer a terse response. 20.83. What is the difference between the Claims(annual growth as % of broad money) in Angola in 2009 and the Claims(annual growth as % of broad money) in Mexico in 2010?
Keep it short and to the point. 16.1. What is the difference between the Claims(annual growth as % of broad money) in Angola in 2009 and the Claims(annual growth as % of broad money) in Moldova in 2010?
Make the answer very short. 16.08. What is the difference between the Claims(annual growth as % of broad money) in Kuwait in 2009 and the Claims(annual growth as % of broad money) in Mexico in 2010?
Offer a terse response. -0.55. What is the difference between the Claims(annual growth as % of broad money) in Kuwait in 2009 and the Claims(annual growth as % of broad money) in Moldova in 2010?
Keep it short and to the point. -0.57. What is the difference between the Claims(annual growth as % of broad money) of Mexico in 2009 and the Claims(annual growth as % of broad money) of Moldova in 2010?
Offer a very short reply. -3.82. What is the average Claims(annual growth as % of broad money) of Angola per year?
Keep it short and to the point. 24.16. What is the average Claims(annual growth as % of broad money) in Kuwait per year?
Provide a succinct answer. 15.72. What is the average Claims(annual growth as % of broad money) in Mexico per year?
Keep it short and to the point. 6.91. What is the average Claims(annual growth as % of broad money) of Moldova per year?
Your response must be concise. 17.07. In the year 2003, what is the difference between the Claims(annual growth as % of broad money) in Angola and Claims(annual growth as % of broad money) in Kuwait?
Provide a short and direct response. 10.96. In the year 2003, what is the difference between the Claims(annual growth as % of broad money) of Angola and Claims(annual growth as % of broad money) of Mexico?
Make the answer very short. 24.95. In the year 2003, what is the difference between the Claims(annual growth as % of broad money) in Angola and Claims(annual growth as % of broad money) in Moldova?
Your answer should be compact. 2.25. In the year 2003, what is the difference between the Claims(annual growth as % of broad money) of Kuwait and Claims(annual growth as % of broad money) of Mexico?
Keep it short and to the point. 13.99. In the year 2003, what is the difference between the Claims(annual growth as % of broad money) in Kuwait and Claims(annual growth as % of broad money) in Moldova?
Your answer should be very brief. -8.71. In the year 2003, what is the difference between the Claims(annual growth as % of broad money) of Mexico and Claims(annual growth as % of broad money) of Moldova?
Offer a very short reply. -22.7. In the year 2004, what is the difference between the Claims(annual growth as % of broad money) of Angola and Claims(annual growth as % of broad money) of Kuwait?
Provide a succinct answer. 6.34. In the year 2004, what is the difference between the Claims(annual growth as % of broad money) of Angola and Claims(annual growth as % of broad money) of Mexico?
Provide a succinct answer. 16.09. In the year 2004, what is the difference between the Claims(annual growth as % of broad money) of Angola and Claims(annual growth as % of broad money) of Moldova?
Provide a succinct answer. 5.75. In the year 2004, what is the difference between the Claims(annual growth as % of broad money) in Kuwait and Claims(annual growth as % of broad money) in Mexico?
Make the answer very short. 9.75. In the year 2004, what is the difference between the Claims(annual growth as % of broad money) of Kuwait and Claims(annual growth as % of broad money) of Moldova?
Offer a very short reply. -0.6. In the year 2004, what is the difference between the Claims(annual growth as % of broad money) in Mexico and Claims(annual growth as % of broad money) in Moldova?
Provide a succinct answer. -10.35. In the year 2005, what is the difference between the Claims(annual growth as % of broad money) of Angola and Claims(annual growth as % of broad money) of Kuwait?
Provide a short and direct response. -0.08. In the year 2005, what is the difference between the Claims(annual growth as % of broad money) of Angola and Claims(annual growth as % of broad money) of Mexico?
Provide a succinct answer. 9.56. In the year 2005, what is the difference between the Claims(annual growth as % of broad money) in Angola and Claims(annual growth as % of broad money) in Moldova?
Offer a terse response. 0.51. In the year 2005, what is the difference between the Claims(annual growth as % of broad money) of Kuwait and Claims(annual growth as % of broad money) of Mexico?
Make the answer very short. 9.64. In the year 2005, what is the difference between the Claims(annual growth as % of broad money) in Kuwait and Claims(annual growth as % of broad money) in Moldova?
Make the answer very short. 0.59. In the year 2005, what is the difference between the Claims(annual growth as % of broad money) of Mexico and Claims(annual growth as % of broad money) of Moldova?
Offer a terse response. -9.05. In the year 2006, what is the difference between the Claims(annual growth as % of broad money) of Angola and Claims(annual growth as % of broad money) of Kuwait?
Give a very brief answer. 10.91. In the year 2006, what is the difference between the Claims(annual growth as % of broad money) in Angola and Claims(annual growth as % of broad money) in Mexico?
Make the answer very short. 15.5. In the year 2006, what is the difference between the Claims(annual growth as % of broad money) of Angola and Claims(annual growth as % of broad money) of Moldova?
Your answer should be very brief. 10.03. In the year 2006, what is the difference between the Claims(annual growth as % of broad money) of Kuwait and Claims(annual growth as % of broad money) of Mexico?
Provide a succinct answer. 4.59. In the year 2006, what is the difference between the Claims(annual growth as % of broad money) in Kuwait and Claims(annual growth as % of broad money) in Moldova?
Make the answer very short. -0.88. In the year 2006, what is the difference between the Claims(annual growth as % of broad money) in Mexico and Claims(annual growth as % of broad money) in Moldova?
Your response must be concise. -5.47. In the year 2007, what is the difference between the Claims(annual growth as % of broad money) in Angola and Claims(annual growth as % of broad money) in Kuwait?
Offer a terse response. 2.48. In the year 2007, what is the difference between the Claims(annual growth as % of broad money) of Angola and Claims(annual growth as % of broad money) of Mexico?
Your answer should be very brief. 20.43. In the year 2007, what is the difference between the Claims(annual growth as % of broad money) of Angola and Claims(annual growth as % of broad money) of Moldova?
Offer a terse response. -5.85. In the year 2007, what is the difference between the Claims(annual growth as % of broad money) in Kuwait and Claims(annual growth as % of broad money) in Mexico?
Offer a very short reply. 17.95. In the year 2007, what is the difference between the Claims(annual growth as % of broad money) of Kuwait and Claims(annual growth as % of broad money) of Moldova?
Provide a succinct answer. -8.33. In the year 2007, what is the difference between the Claims(annual growth as % of broad money) in Mexico and Claims(annual growth as % of broad money) in Moldova?
Your answer should be very brief. -26.28. In the year 2008, what is the difference between the Claims(annual growth as % of broad money) in Angola and Claims(annual growth as % of broad money) in Kuwait?
Provide a short and direct response. 12.86. In the year 2008, what is the difference between the Claims(annual growth as % of broad money) in Angola and Claims(annual growth as % of broad money) in Mexico?
Your response must be concise. 28.9. In the year 2008, what is the difference between the Claims(annual growth as % of broad money) in Angola and Claims(annual growth as % of broad money) in Moldova?
Offer a very short reply. 18.27. In the year 2008, what is the difference between the Claims(annual growth as % of broad money) in Kuwait and Claims(annual growth as % of broad money) in Mexico?
Ensure brevity in your answer.  16.04. In the year 2008, what is the difference between the Claims(annual growth as % of broad money) in Kuwait and Claims(annual growth as % of broad money) in Moldova?
Offer a very short reply. 5.41. In the year 2008, what is the difference between the Claims(annual growth as % of broad money) of Mexico and Claims(annual growth as % of broad money) of Moldova?
Keep it short and to the point. -10.63. In the year 2009, what is the difference between the Claims(annual growth as % of broad money) of Angola and Claims(annual growth as % of broad money) of Kuwait?
Make the answer very short. 16.65. In the year 2009, what is the difference between the Claims(annual growth as % of broad money) in Angola and Claims(annual growth as % of broad money) in Mexico?
Your answer should be compact. 19.91. In the year 2009, what is the difference between the Claims(annual growth as % of broad money) of Kuwait and Claims(annual growth as % of broad money) of Mexico?
Offer a terse response. 3.26. In the year 2010, what is the difference between the Claims(annual growth as % of broad money) in Angola and Claims(annual growth as % of broad money) in Kuwait?
Your answer should be compact. 7.38. In the year 2010, what is the difference between the Claims(annual growth as % of broad money) of Angola and Claims(annual growth as % of broad money) of Mexico?
Ensure brevity in your answer.  2.65. In the year 2010, what is the difference between the Claims(annual growth as % of broad money) of Angola and Claims(annual growth as % of broad money) of Moldova?
Offer a very short reply. 2.63. In the year 2010, what is the difference between the Claims(annual growth as % of broad money) in Kuwait and Claims(annual growth as % of broad money) in Mexico?
Keep it short and to the point. -4.73. In the year 2010, what is the difference between the Claims(annual growth as % of broad money) in Kuwait and Claims(annual growth as % of broad money) in Moldova?
Offer a terse response. -4.75. In the year 2010, what is the difference between the Claims(annual growth as % of broad money) in Mexico and Claims(annual growth as % of broad money) in Moldova?
Ensure brevity in your answer.  -0.02. What is the ratio of the Claims(annual growth as % of broad money) in Angola in 2003 to that in 2004?
Your answer should be very brief. 1.46. What is the ratio of the Claims(annual growth as % of broad money) of Kuwait in 2003 to that in 2004?
Make the answer very short. 1.34. What is the ratio of the Claims(annual growth as % of broad money) in Mexico in 2003 to that in 2004?
Your response must be concise. 1.07. What is the ratio of the Claims(annual growth as % of broad money) in Moldova in 2003 to that in 2004?
Provide a short and direct response. 1.9. What is the ratio of the Claims(annual growth as % of broad money) of Angola in 2003 to that in 2005?
Your response must be concise. 1.58. What is the ratio of the Claims(annual growth as % of broad money) of Kuwait in 2003 to that in 2005?
Keep it short and to the point. 0.97. What is the ratio of the Claims(annual growth as % of broad money) in Mexico in 2003 to that in 2005?
Your answer should be compact. 0.45. What is the ratio of the Claims(annual growth as % of broad money) in Moldova in 2003 to that in 2005?
Offer a very short reply. 1.5. What is the ratio of the Claims(annual growth as % of broad money) of Angola in 2003 to that in 2006?
Make the answer very short. 0.91. What is the ratio of the Claims(annual growth as % of broad money) in Kuwait in 2003 to that in 2006?
Your answer should be compact. 0.86. What is the ratio of the Claims(annual growth as % of broad money) of Mexico in 2003 to that in 2006?
Give a very brief answer. 0.24. What is the ratio of the Claims(annual growth as % of broad money) of Moldova in 2003 to that in 2006?
Your answer should be very brief. 1.23. What is the ratio of the Claims(annual growth as % of broad money) in Angola in 2003 to that in 2007?
Keep it short and to the point. 0.9. What is the ratio of the Claims(annual growth as % of broad money) of Kuwait in 2003 to that in 2007?
Your answer should be compact. 0.61. What is the ratio of the Claims(annual growth as % of broad money) of Mexico in 2003 to that in 2007?
Offer a terse response. 0.34. What is the ratio of the Claims(annual growth as % of broad money) of Moldova in 2003 to that in 2007?
Offer a very short reply. 0.7. What is the ratio of the Claims(annual growth as % of broad money) of Angola in 2003 to that in 2008?
Provide a short and direct response. 0.96. What is the ratio of the Claims(annual growth as % of broad money) in Mexico in 2003 to that in 2008?
Provide a succinct answer. 3.12. What is the ratio of the Claims(annual growth as % of broad money) in Moldova in 2003 to that in 2008?
Your answer should be very brief. 2.24. What is the ratio of the Claims(annual growth as % of broad money) in Angola in 2003 to that in 2009?
Give a very brief answer. 1.25. What is the ratio of the Claims(annual growth as % of broad money) of Kuwait in 2003 to that in 2009?
Your answer should be compact. 2.75. What is the ratio of the Claims(annual growth as % of broad money) in Mexico in 2003 to that in 2009?
Keep it short and to the point. 1.2. What is the ratio of the Claims(annual growth as % of broad money) of Angola in 2003 to that in 2010?
Provide a succinct answer. 2.97. What is the ratio of the Claims(annual growth as % of broad money) in Kuwait in 2003 to that in 2010?
Offer a very short reply. 7.72. What is the ratio of the Claims(annual growth as % of broad money) in Mexico in 2003 to that in 2010?
Ensure brevity in your answer.  0.55. What is the ratio of the Claims(annual growth as % of broad money) of Moldova in 2003 to that in 2010?
Give a very brief answer. 3.76. What is the ratio of the Claims(annual growth as % of broad money) of Angola in 2004 to that in 2005?
Provide a succinct answer. 1.08. What is the ratio of the Claims(annual growth as % of broad money) in Kuwait in 2004 to that in 2005?
Keep it short and to the point. 0.73. What is the ratio of the Claims(annual growth as % of broad money) of Mexico in 2004 to that in 2005?
Your response must be concise. 0.41. What is the ratio of the Claims(annual growth as % of broad money) in Moldova in 2004 to that in 2005?
Offer a very short reply. 0.79. What is the ratio of the Claims(annual growth as % of broad money) in Angola in 2004 to that in 2006?
Your response must be concise. 0.62. What is the ratio of the Claims(annual growth as % of broad money) of Kuwait in 2004 to that in 2006?
Offer a terse response. 0.65. What is the ratio of the Claims(annual growth as % of broad money) in Mexico in 2004 to that in 2006?
Provide a short and direct response. 0.22. What is the ratio of the Claims(annual growth as % of broad money) in Moldova in 2004 to that in 2006?
Your response must be concise. 0.65. What is the ratio of the Claims(annual growth as % of broad money) of Angola in 2004 to that in 2007?
Make the answer very short. 0.62. What is the ratio of the Claims(annual growth as % of broad money) in Kuwait in 2004 to that in 2007?
Make the answer very short. 0.45. What is the ratio of the Claims(annual growth as % of broad money) of Mexico in 2004 to that in 2007?
Your answer should be very brief. 0.31. What is the ratio of the Claims(annual growth as % of broad money) in Moldova in 2004 to that in 2007?
Offer a very short reply. 0.37. What is the ratio of the Claims(annual growth as % of broad money) in Angola in 2004 to that in 2008?
Keep it short and to the point. 0.65. What is the ratio of the Claims(annual growth as % of broad money) in Kuwait in 2004 to that in 2008?
Your answer should be compact. 0.77. What is the ratio of the Claims(annual growth as % of broad money) of Mexico in 2004 to that in 2008?
Make the answer very short. 2.9. What is the ratio of the Claims(annual growth as % of broad money) of Moldova in 2004 to that in 2008?
Ensure brevity in your answer.  1.18. What is the ratio of the Claims(annual growth as % of broad money) in Angola in 2004 to that in 2009?
Your answer should be very brief. 0.85. What is the ratio of the Claims(annual growth as % of broad money) of Kuwait in 2004 to that in 2009?
Make the answer very short. 2.06. What is the ratio of the Claims(annual growth as % of broad money) in Mexico in 2004 to that in 2009?
Give a very brief answer. 1.11. What is the ratio of the Claims(annual growth as % of broad money) of Angola in 2004 to that in 2010?
Ensure brevity in your answer.  2.03. What is the ratio of the Claims(annual growth as % of broad money) of Kuwait in 2004 to that in 2010?
Offer a very short reply. 5.77. What is the ratio of the Claims(annual growth as % of broad money) of Mexico in 2004 to that in 2010?
Your answer should be very brief. 0.51. What is the ratio of the Claims(annual growth as % of broad money) in Moldova in 2004 to that in 2010?
Your response must be concise. 1.98. What is the ratio of the Claims(annual growth as % of broad money) in Angola in 2005 to that in 2006?
Make the answer very short. 0.58. What is the ratio of the Claims(annual growth as % of broad money) of Kuwait in 2005 to that in 2006?
Keep it short and to the point. 0.89. What is the ratio of the Claims(annual growth as % of broad money) of Mexico in 2005 to that in 2006?
Provide a succinct answer. 0.54. What is the ratio of the Claims(annual growth as % of broad money) in Moldova in 2005 to that in 2006?
Keep it short and to the point. 0.82. What is the ratio of the Claims(annual growth as % of broad money) in Angola in 2005 to that in 2007?
Your response must be concise. 0.57. What is the ratio of the Claims(annual growth as % of broad money) in Kuwait in 2005 to that in 2007?
Provide a succinct answer. 0.62. What is the ratio of the Claims(annual growth as % of broad money) of Mexico in 2005 to that in 2007?
Offer a very short reply. 0.76. What is the ratio of the Claims(annual growth as % of broad money) of Moldova in 2005 to that in 2007?
Give a very brief answer. 0.47. What is the ratio of the Claims(annual growth as % of broad money) of Angola in 2005 to that in 2008?
Your answer should be compact. 0.61. What is the ratio of the Claims(annual growth as % of broad money) of Kuwait in 2005 to that in 2008?
Ensure brevity in your answer.  1.06. What is the ratio of the Claims(annual growth as % of broad money) in Mexico in 2005 to that in 2008?
Your answer should be very brief. 7. What is the ratio of the Claims(annual growth as % of broad money) in Moldova in 2005 to that in 2008?
Your response must be concise. 1.5. What is the ratio of the Claims(annual growth as % of broad money) of Angola in 2005 to that in 2009?
Offer a terse response. 0.79. What is the ratio of the Claims(annual growth as % of broad money) of Kuwait in 2005 to that in 2009?
Ensure brevity in your answer.  2.82. What is the ratio of the Claims(annual growth as % of broad money) of Mexico in 2005 to that in 2009?
Provide a succinct answer. 2.69. What is the ratio of the Claims(annual growth as % of broad money) of Angola in 2005 to that in 2010?
Offer a very short reply. 1.88. What is the ratio of the Claims(annual growth as % of broad money) of Kuwait in 2005 to that in 2010?
Ensure brevity in your answer.  7.93. What is the ratio of the Claims(annual growth as % of broad money) in Mexico in 2005 to that in 2010?
Keep it short and to the point. 1.24. What is the ratio of the Claims(annual growth as % of broad money) in Moldova in 2005 to that in 2010?
Your response must be concise. 2.51. What is the ratio of the Claims(annual growth as % of broad money) of Kuwait in 2006 to that in 2007?
Ensure brevity in your answer.  0.7. What is the ratio of the Claims(annual growth as % of broad money) in Mexico in 2006 to that in 2007?
Offer a very short reply. 1.4. What is the ratio of the Claims(annual growth as % of broad money) of Moldova in 2006 to that in 2007?
Provide a succinct answer. 0.57. What is the ratio of the Claims(annual growth as % of broad money) of Angola in 2006 to that in 2008?
Your answer should be compact. 1.05. What is the ratio of the Claims(annual growth as % of broad money) in Kuwait in 2006 to that in 2008?
Your answer should be very brief. 1.2. What is the ratio of the Claims(annual growth as % of broad money) in Mexico in 2006 to that in 2008?
Your answer should be very brief. 12.94. What is the ratio of the Claims(annual growth as % of broad money) of Moldova in 2006 to that in 2008?
Provide a short and direct response. 1.81. What is the ratio of the Claims(annual growth as % of broad money) of Angola in 2006 to that in 2009?
Make the answer very short. 1.36. What is the ratio of the Claims(annual growth as % of broad money) of Kuwait in 2006 to that in 2009?
Keep it short and to the point. 3.18. What is the ratio of the Claims(annual growth as % of broad money) of Mexico in 2006 to that in 2009?
Offer a very short reply. 4.96. What is the ratio of the Claims(annual growth as % of broad money) in Angola in 2006 to that in 2010?
Your answer should be compact. 3.26. What is the ratio of the Claims(annual growth as % of broad money) in Kuwait in 2006 to that in 2010?
Your answer should be compact. 8.93. What is the ratio of the Claims(annual growth as % of broad money) in Mexico in 2006 to that in 2010?
Your answer should be compact. 2.28. What is the ratio of the Claims(annual growth as % of broad money) of Moldova in 2006 to that in 2010?
Give a very brief answer. 3.05. What is the ratio of the Claims(annual growth as % of broad money) in Angola in 2007 to that in 2008?
Keep it short and to the point. 1.06. What is the ratio of the Claims(annual growth as % of broad money) in Kuwait in 2007 to that in 2008?
Keep it short and to the point. 1.7. What is the ratio of the Claims(annual growth as % of broad money) of Mexico in 2007 to that in 2008?
Make the answer very short. 9.27. What is the ratio of the Claims(annual growth as % of broad money) in Moldova in 2007 to that in 2008?
Provide a short and direct response. 3.18. What is the ratio of the Claims(annual growth as % of broad money) of Angola in 2007 to that in 2009?
Offer a terse response. 1.38. What is the ratio of the Claims(annual growth as % of broad money) of Kuwait in 2007 to that in 2009?
Your answer should be very brief. 4.54. What is the ratio of the Claims(annual growth as % of broad money) of Mexico in 2007 to that in 2009?
Make the answer very short. 3.55. What is the ratio of the Claims(annual growth as % of broad money) in Angola in 2007 to that in 2010?
Keep it short and to the point. 3.3. What is the ratio of the Claims(annual growth as % of broad money) of Kuwait in 2007 to that in 2010?
Give a very brief answer. 12.73. What is the ratio of the Claims(annual growth as % of broad money) of Mexico in 2007 to that in 2010?
Make the answer very short. 1.63. What is the ratio of the Claims(annual growth as % of broad money) in Moldova in 2007 to that in 2010?
Offer a very short reply. 5.35. What is the ratio of the Claims(annual growth as % of broad money) in Angola in 2008 to that in 2009?
Offer a terse response. 1.3. What is the ratio of the Claims(annual growth as % of broad money) in Kuwait in 2008 to that in 2009?
Keep it short and to the point. 2.66. What is the ratio of the Claims(annual growth as % of broad money) in Mexico in 2008 to that in 2009?
Your answer should be compact. 0.38. What is the ratio of the Claims(annual growth as % of broad money) in Angola in 2008 to that in 2010?
Your answer should be very brief. 3.11. What is the ratio of the Claims(annual growth as % of broad money) of Kuwait in 2008 to that in 2010?
Keep it short and to the point. 7.47. What is the ratio of the Claims(annual growth as % of broad money) of Mexico in 2008 to that in 2010?
Your response must be concise. 0.18. What is the ratio of the Claims(annual growth as % of broad money) in Moldova in 2008 to that in 2010?
Provide a short and direct response. 1.68. What is the ratio of the Claims(annual growth as % of broad money) of Angola in 2009 to that in 2010?
Provide a short and direct response. 2.39. What is the ratio of the Claims(annual growth as % of broad money) in Kuwait in 2009 to that in 2010?
Your answer should be very brief. 2.81. What is the ratio of the Claims(annual growth as % of broad money) of Mexico in 2009 to that in 2010?
Offer a terse response. 0.46. What is the difference between the highest and the second highest Claims(annual growth as % of broad money) of Angola?
Your answer should be very brief. 0.37. What is the difference between the highest and the second highest Claims(annual growth as % of broad money) of Kuwait?
Offer a terse response. 8.79. What is the difference between the highest and the second highest Claims(annual growth as % of broad money) in Mexico?
Your answer should be very brief. 4.56. What is the difference between the highest and the second highest Claims(annual growth as % of broad money) in Moldova?
Your answer should be very brief. 11.22. What is the difference between the highest and the lowest Claims(annual growth as % of broad money) in Angola?
Give a very brief answer. 22.25. What is the difference between the highest and the lowest Claims(annual growth as % of broad money) of Kuwait?
Keep it short and to the point. 27.15. What is the difference between the highest and the lowest Claims(annual growth as % of broad money) of Mexico?
Make the answer very short. 14.83. What is the difference between the highest and the lowest Claims(annual growth as % of broad money) of Moldova?
Make the answer very short. 37.79. 